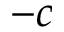<formula> <loc_0><loc_0><loc_500><loc_500>- c</formula> 